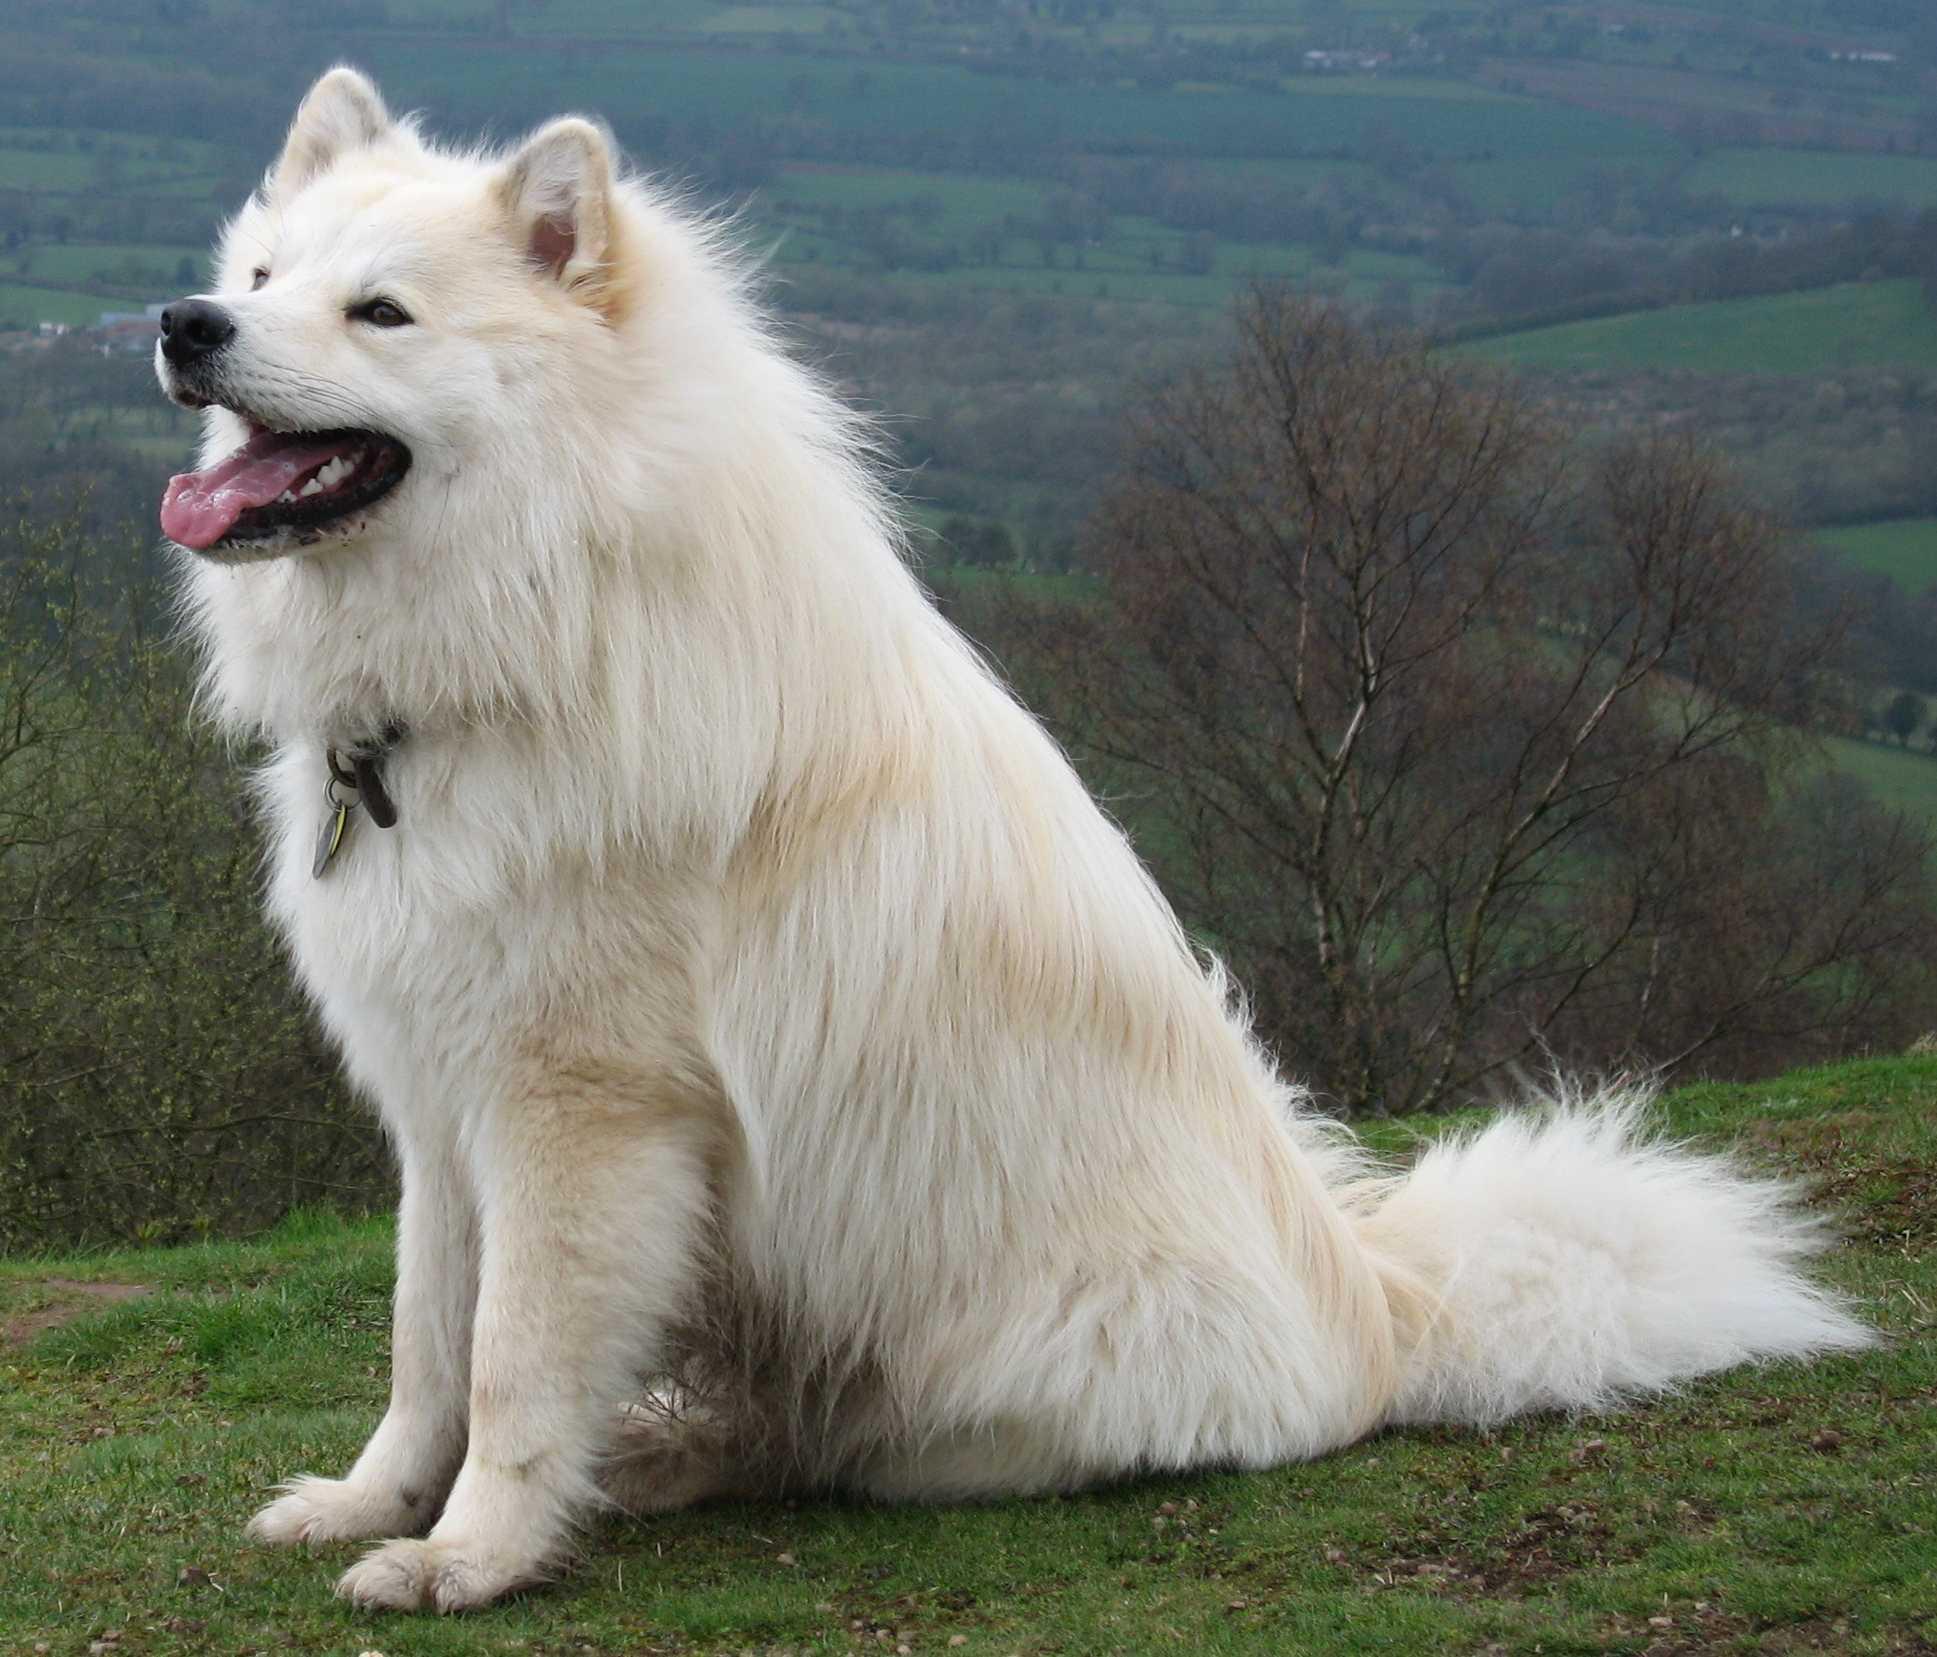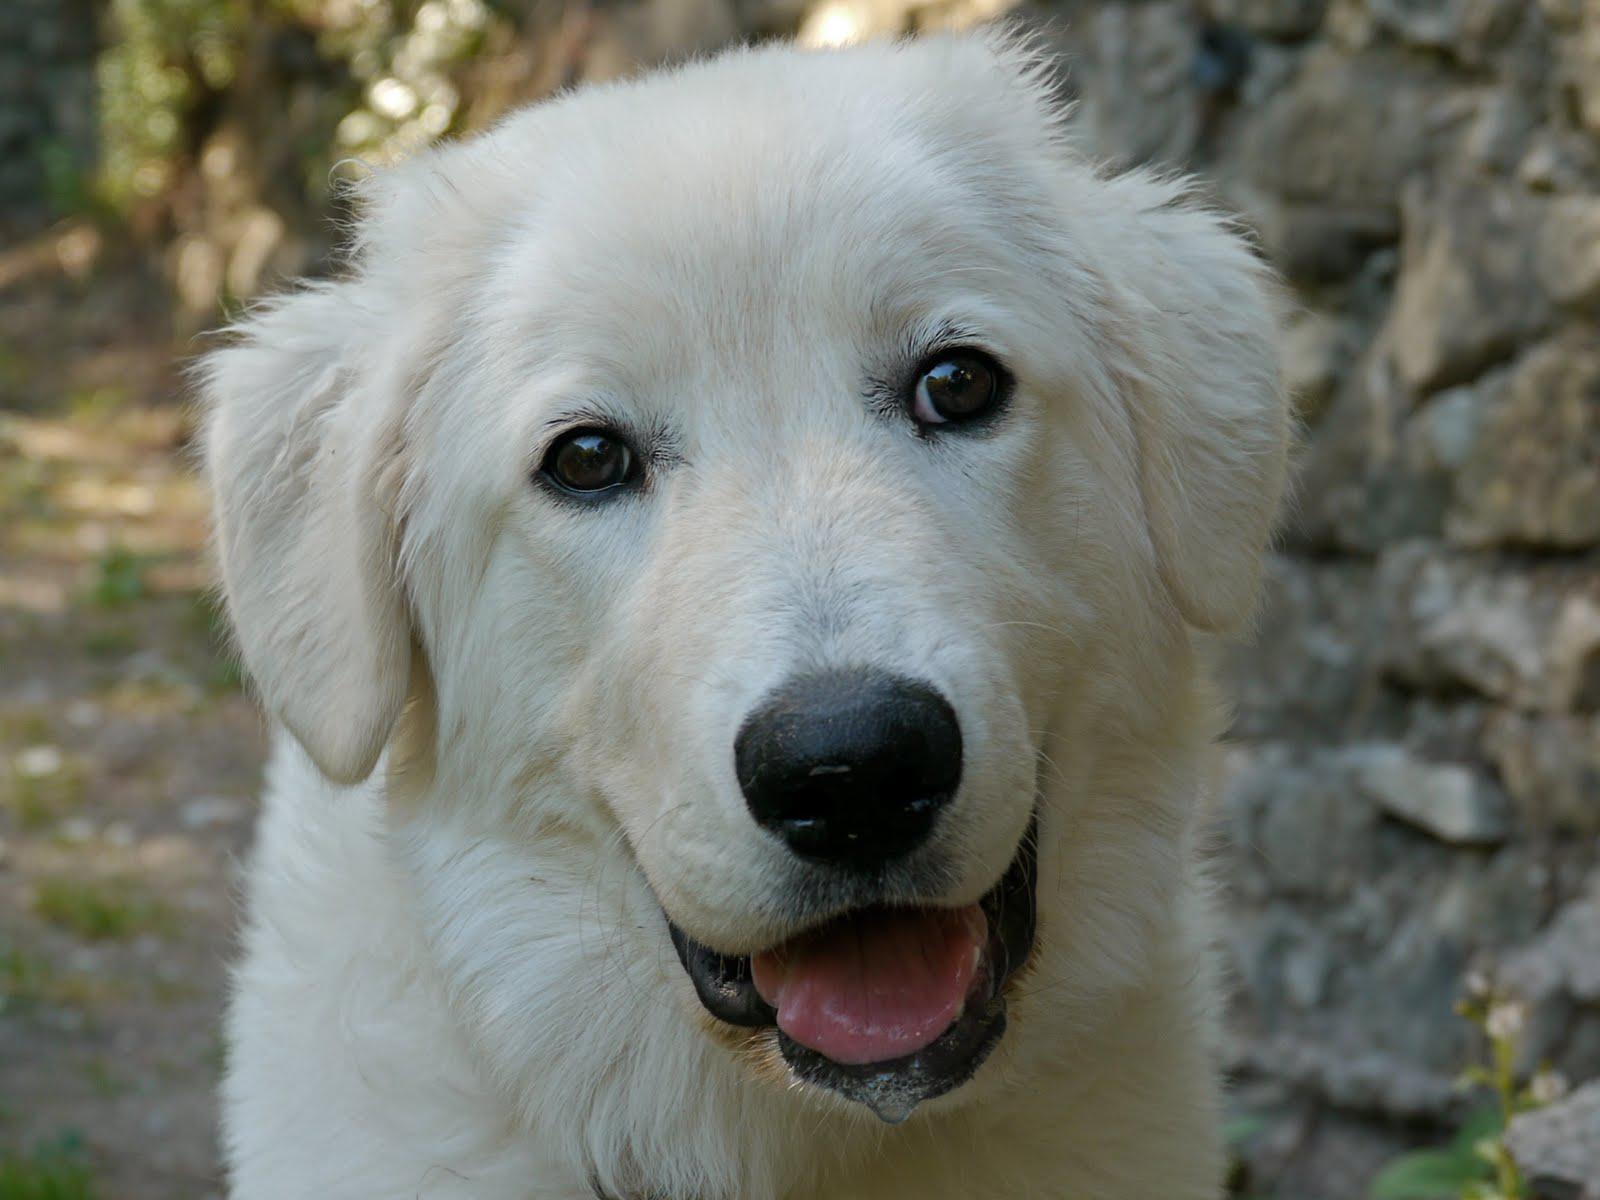The first image is the image on the left, the second image is the image on the right. For the images shown, is this caption "A white dog is standing and facing right" true? Answer yes or no. No. 